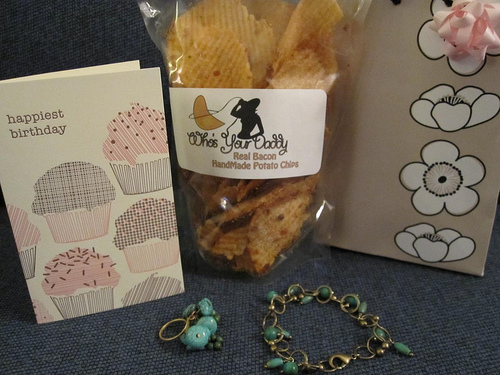<image>
Is there a bow above the card? Yes. The bow is positioned above the card in the vertical space, higher up in the scene. 